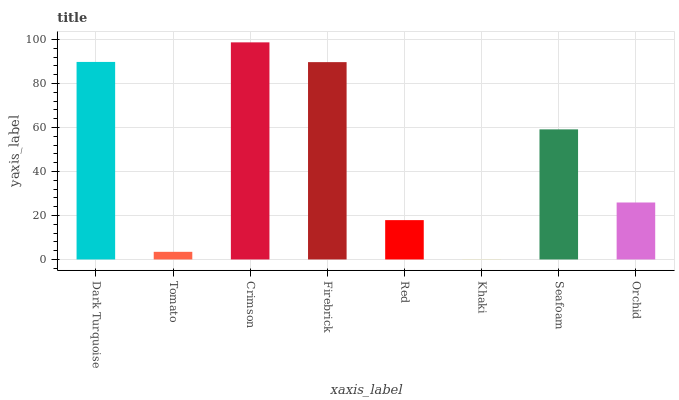Is Khaki the minimum?
Answer yes or no. Yes. Is Crimson the maximum?
Answer yes or no. Yes. Is Tomato the minimum?
Answer yes or no. No. Is Tomato the maximum?
Answer yes or no. No. Is Dark Turquoise greater than Tomato?
Answer yes or no. Yes. Is Tomato less than Dark Turquoise?
Answer yes or no. Yes. Is Tomato greater than Dark Turquoise?
Answer yes or no. No. Is Dark Turquoise less than Tomato?
Answer yes or no. No. Is Seafoam the high median?
Answer yes or no. Yes. Is Orchid the low median?
Answer yes or no. Yes. Is Orchid the high median?
Answer yes or no. No. Is Red the low median?
Answer yes or no. No. 